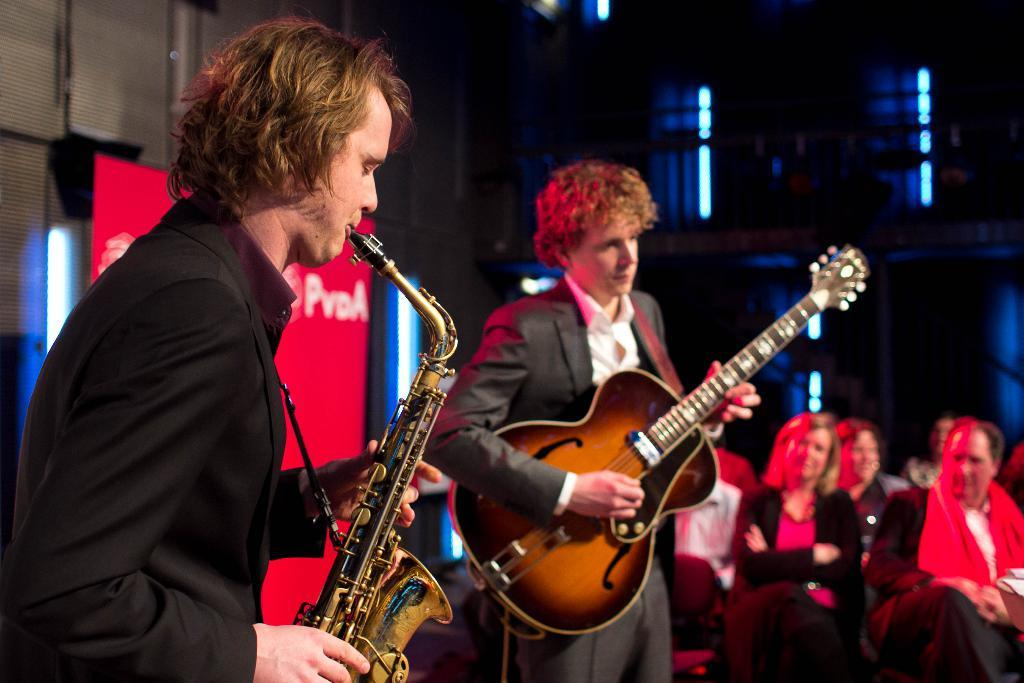How many people are standing in the image? There are two persons standing in the image. What is one person holding in the image? One person is holding a guitar. What is the other person doing in the image? Another person is playing a musical instrument. Are there any people sitting in the image? Yes, there are persons sitting in the image. What can be seen in the background of the image? There is a banner visible in the background of the image. What type of spark can be seen in the middle of the image? There is no spark present in the image. Is there a meeting taking place in the image? The image does not depict a meeting; it shows people playing musical instruments. 